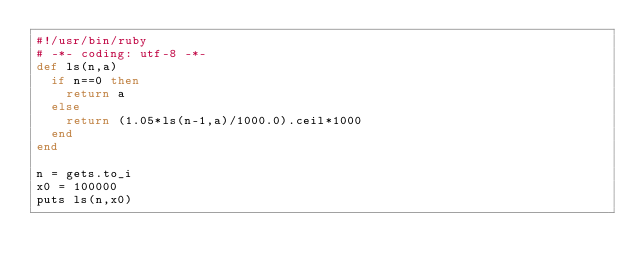<code> <loc_0><loc_0><loc_500><loc_500><_Ruby_>#!/usr/bin/ruby
# -*- coding: utf-8 -*-
def ls(n,a)
  if n==0 then
    return a
  else
    return (1.05*ls(n-1,a)/1000.0).ceil*1000
  end
end

n = gets.to_i
x0 = 100000
puts ls(n,x0)</code> 